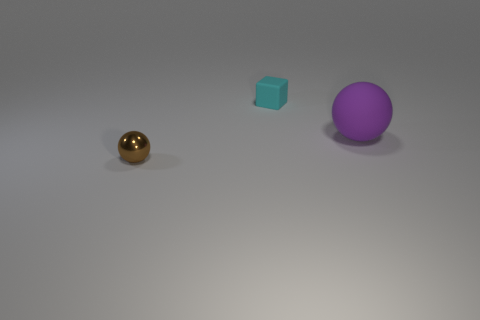Subtract all purple spheres. How many spheres are left? 1 Subtract all blocks. How many objects are left? 2 Add 2 big matte balls. How many objects exist? 5 Subtract 1 spheres. How many spheres are left? 1 Subtract all tiny balls. Subtract all tiny brown metallic objects. How many objects are left? 1 Add 3 cyan rubber objects. How many cyan rubber objects are left? 4 Add 1 large blue matte cylinders. How many large blue matte cylinders exist? 1 Subtract 0 cyan cylinders. How many objects are left? 3 Subtract all green balls. Subtract all blue cubes. How many balls are left? 2 Subtract all red blocks. How many brown balls are left? 1 